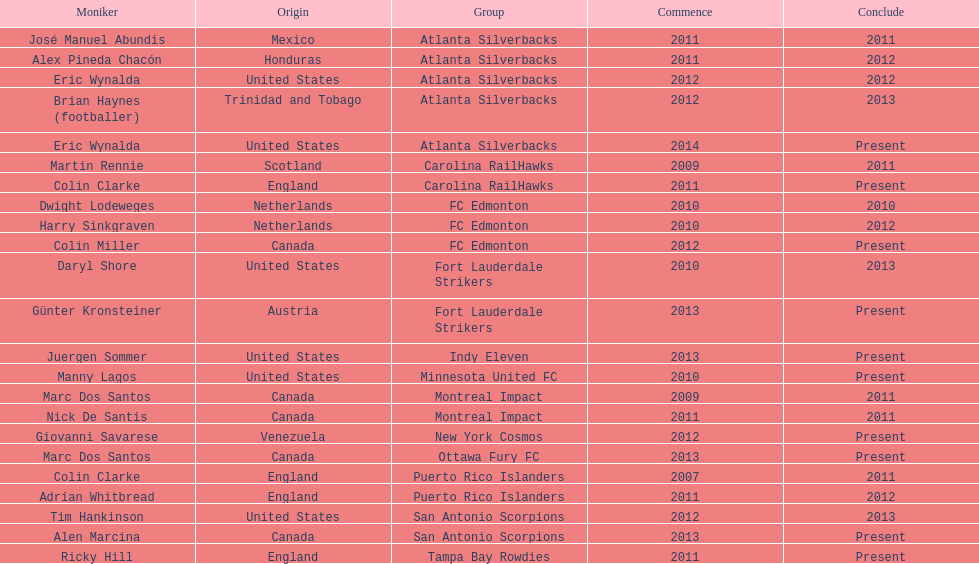Who coached the silverbacks longer, abundis or chacon? Chacon. 